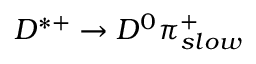<formula> <loc_0><loc_0><loc_500><loc_500>D ^ { * + } \to D ^ { 0 } \pi _ { s l o w } ^ { + }</formula> 